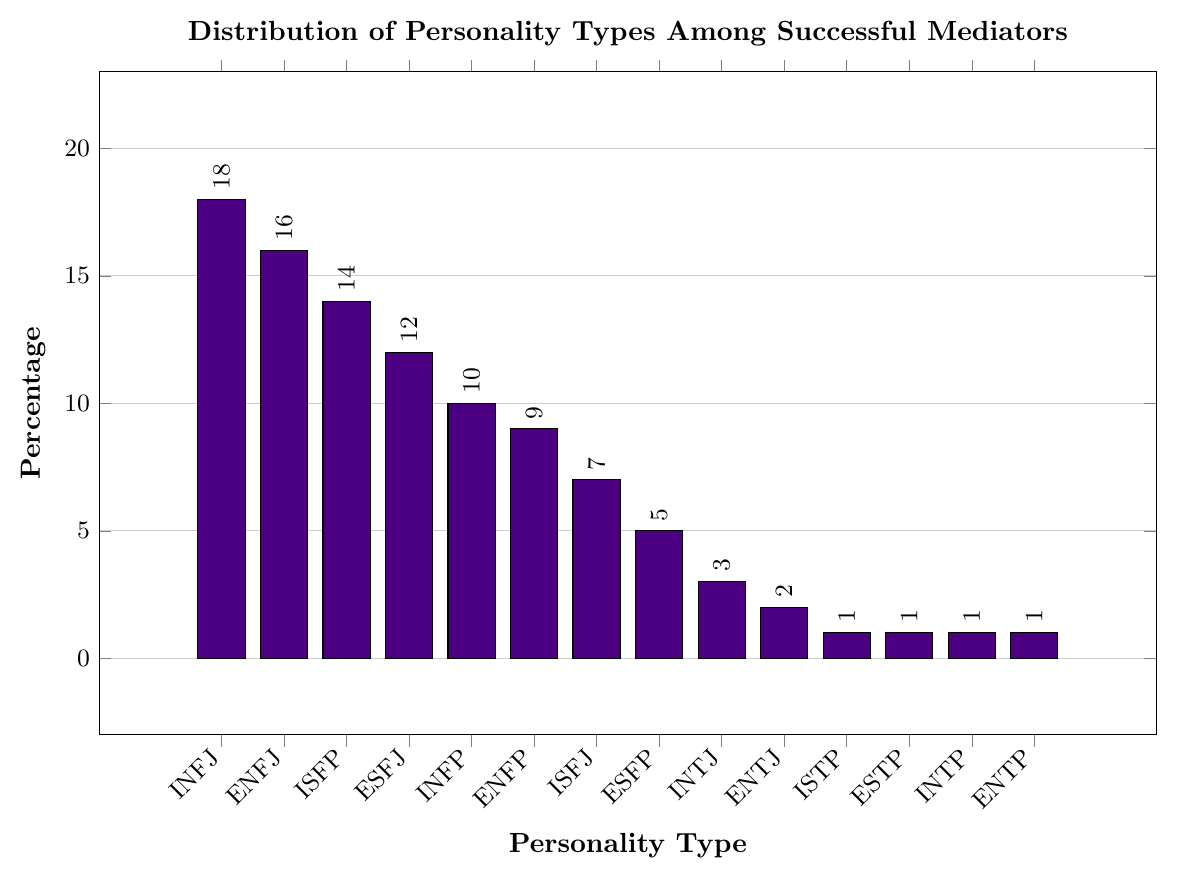What's the most common personality type among successful mediators? The tallest bar in the chart represents the most common personality type. The tallest bar corresponds to INFJ with a height reaching 18%.
Answer: INFJ Which personality type is exactly half as common as INFJ? To find the personality type that is half as common as INFJ, look for a bar that has a height of 9% (since 18% / 2 = 9%). The bar for ENFP is at 9%.
Answer: ENFP How much more common is ENFJ compared to INFP? Subtract the percentage of INFP from the percentage of ENFJ: 16% - 10% = 6%.
Answer: 6% What is the combined percentage of the top three personality types? Add the percentages of the top three personality types: INFJ (18%), ENFJ (16%), ISFP (14%). So, 18% + 16% + 14% = 48%.
Answer: 48% Which personality types have a percentage of 1%? Identify all bars of height 1%. These bars correspond to ISTP, ESTP, INTP, and ENTP.
Answer: ISTP, ESTP, INTP, ENTP What is the difference in percentage between the most common and the least common personality types? Subtract the percentage of the least common types (1%) from the most common type (18%): 18% - 1% = 17%.
Answer: 17% What is the total percentage for all personality types that are below 10%? Add the percentages of personality types that are below 10%: ENFP (9%), ISFJ (7%), ESFP (5%), INTJ (3%), ENTJ (2%), ISTP (1%), ESTP (1%), INTP (1%), ENTP (1%). So, 9% + 7% + 5% + 3% + 2% + 1% + 1% + 1% + 1% = 30%.
Answer: 30% Which personality types have a higher percentage than ESFJ but lower than ISFP? Identify the bars that are taller than ESFJ (12%) but shorter than ISFP (14%): INFP (10%) and ENFP (9%).
Answer: INFP, ENFP What percentage of successful mediators have a personality type starting with "E"? Add the percentages of personality types that start with "E": ENFJ (16%), ESFJ (12%), ENFP (9%), ESFP (5%), ENTJ (2%), ESTP (1%), ENTP (1%). So, 16% + 12% + 9% + 5% + 2% + 1% + 1% = 46%.
Answer: 46% 